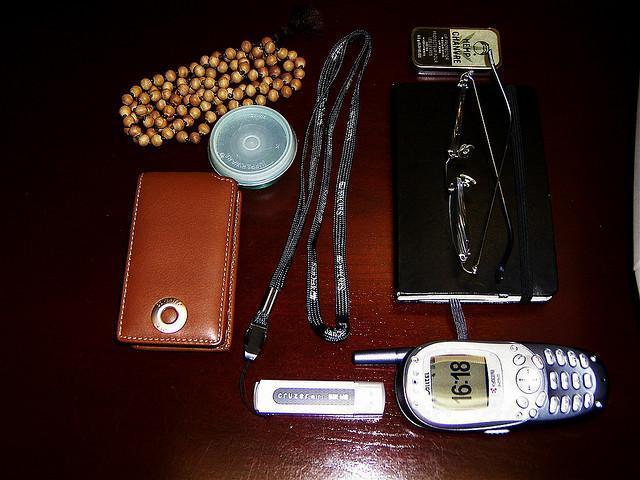How many people are wearing a dress?
Give a very brief answer. 0. 